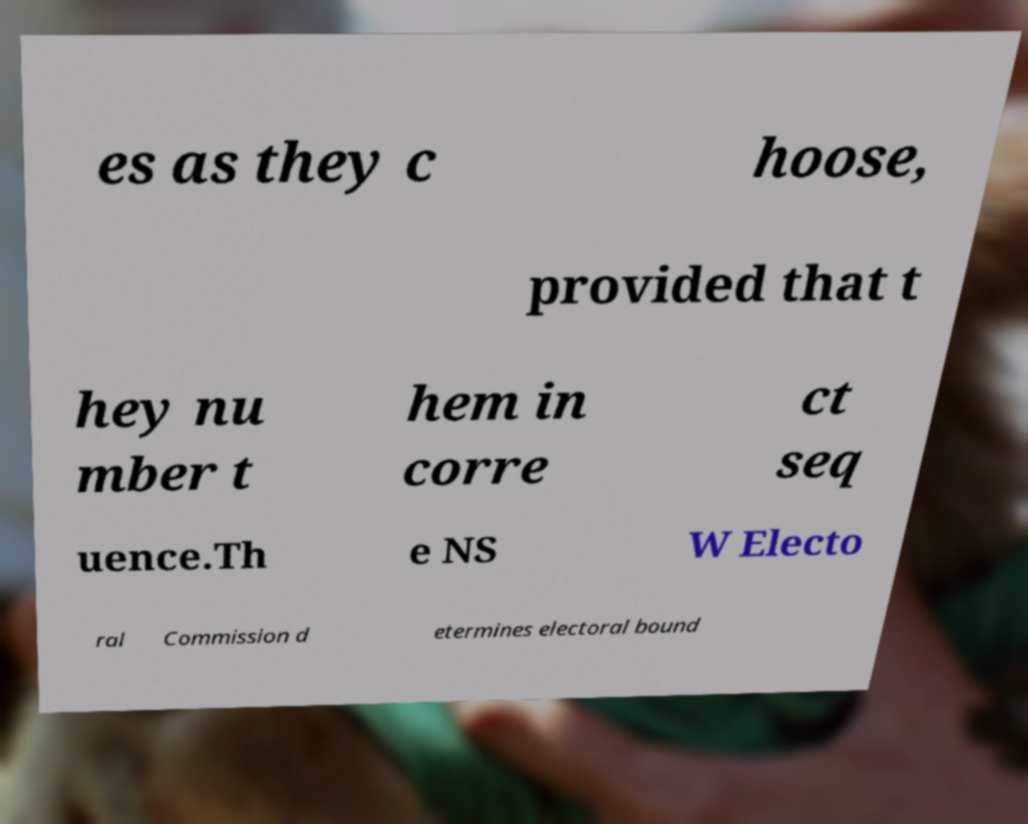Please identify and transcribe the text found in this image. es as they c hoose, provided that t hey nu mber t hem in corre ct seq uence.Th e NS W Electo ral Commission d etermines electoral bound 